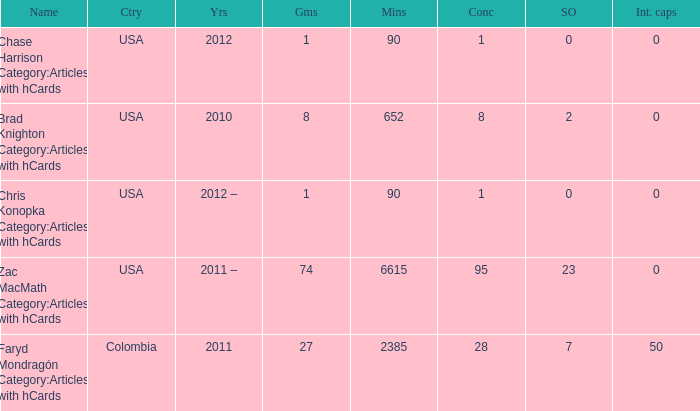When  chris konopka category:articles with hcards is the name what is the year? 2012 –. 